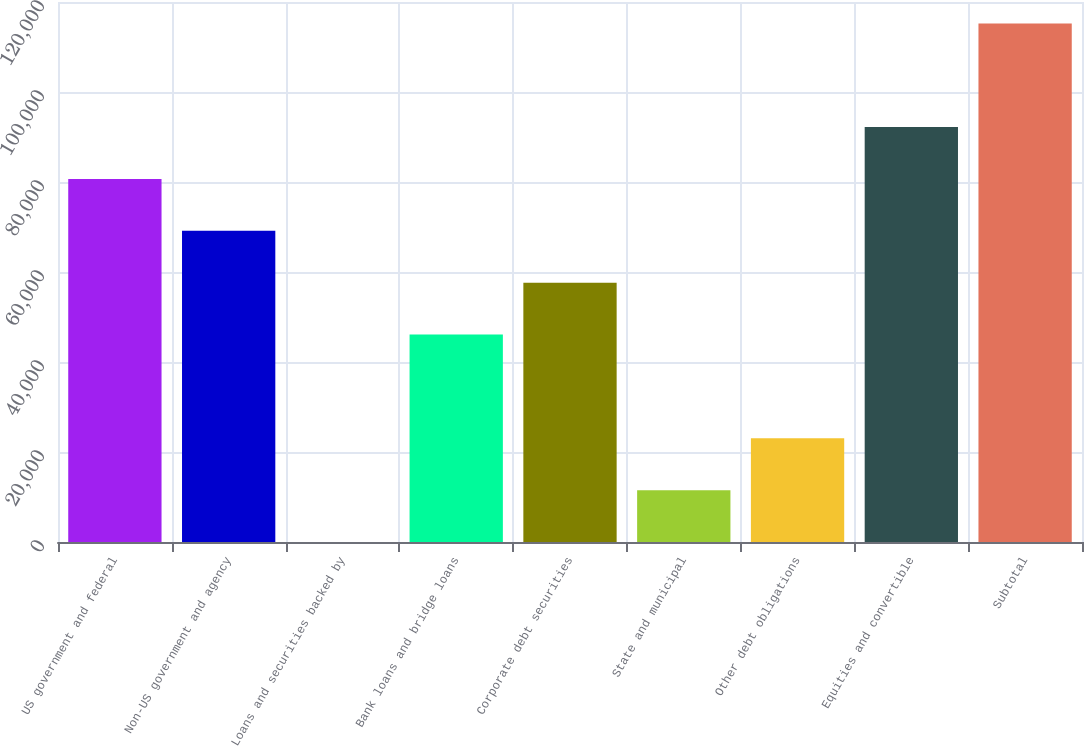Convert chart to OTSL. <chart><loc_0><loc_0><loc_500><loc_500><bar_chart><fcel>US government and federal<fcel>Non-US government and agency<fcel>Loans and securities backed by<fcel>Bank loans and bridge loans<fcel>Corporate debt securities<fcel>State and municipal<fcel>Other debt obligations<fcel>Equities and convertible<fcel>Subtotal<nl><fcel>80674.2<fcel>69149.6<fcel>2<fcel>46100.4<fcel>57625<fcel>11526.6<fcel>23051.2<fcel>92198.8<fcel>115248<nl></chart> 